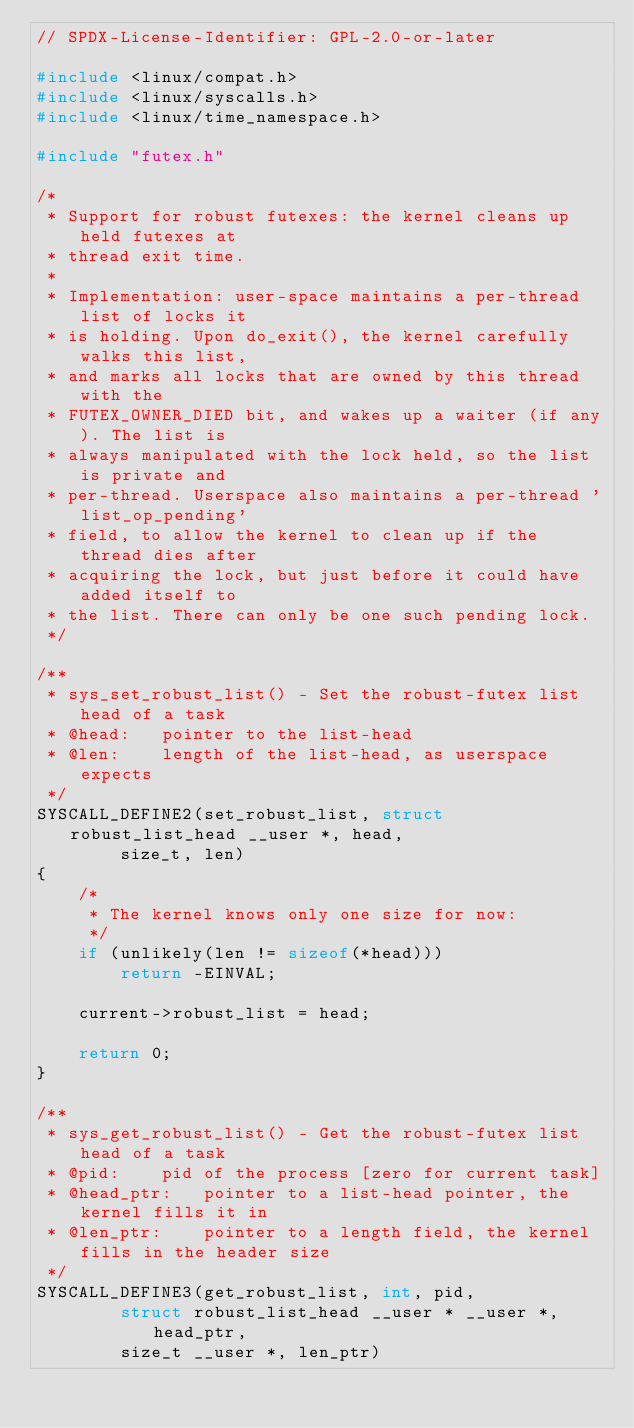Convert code to text. <code><loc_0><loc_0><loc_500><loc_500><_C_>// SPDX-License-Identifier: GPL-2.0-or-later

#include <linux/compat.h>
#include <linux/syscalls.h>
#include <linux/time_namespace.h>

#include "futex.h"

/*
 * Support for robust futexes: the kernel cleans up held futexes at
 * thread exit time.
 *
 * Implementation: user-space maintains a per-thread list of locks it
 * is holding. Upon do_exit(), the kernel carefully walks this list,
 * and marks all locks that are owned by this thread with the
 * FUTEX_OWNER_DIED bit, and wakes up a waiter (if any). The list is
 * always manipulated with the lock held, so the list is private and
 * per-thread. Userspace also maintains a per-thread 'list_op_pending'
 * field, to allow the kernel to clean up if the thread dies after
 * acquiring the lock, but just before it could have added itself to
 * the list. There can only be one such pending lock.
 */

/**
 * sys_set_robust_list() - Set the robust-futex list head of a task
 * @head:	pointer to the list-head
 * @len:	length of the list-head, as userspace expects
 */
SYSCALL_DEFINE2(set_robust_list, struct robust_list_head __user *, head,
		size_t, len)
{
	/*
	 * The kernel knows only one size for now:
	 */
	if (unlikely(len != sizeof(*head)))
		return -EINVAL;

	current->robust_list = head;

	return 0;
}

/**
 * sys_get_robust_list() - Get the robust-futex list head of a task
 * @pid:	pid of the process [zero for current task]
 * @head_ptr:	pointer to a list-head pointer, the kernel fills it in
 * @len_ptr:	pointer to a length field, the kernel fills in the header size
 */
SYSCALL_DEFINE3(get_robust_list, int, pid,
		struct robust_list_head __user * __user *, head_ptr,
		size_t __user *, len_ptr)</code> 